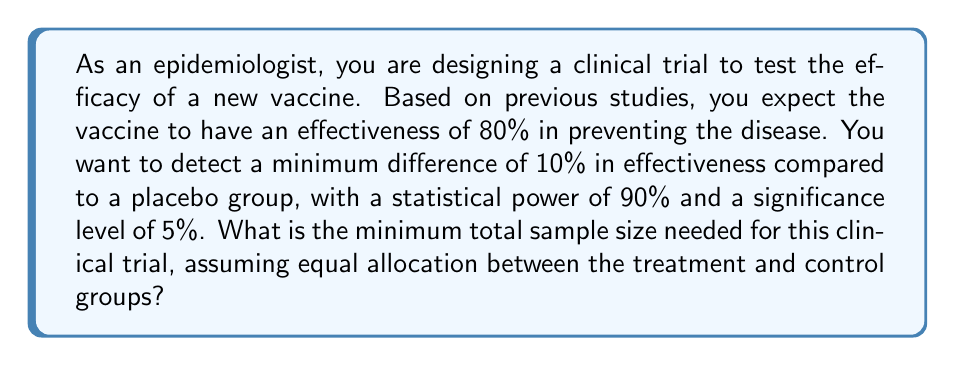What is the answer to this math problem? To calculate the sample size for this clinical trial, we'll use the formula for comparing two proportions:

$$ n = \frac{(z_{\alpha/2} + z_{\beta})^2 [p_1(1-p_1) + p_2(1-p_2)]}{(p_1 - p_2)^2} $$

Where:
- $n$ is the sample size per group
- $z_{\alpha/2}$ is the critical value of the normal distribution at $\alpha/2$
- $z_{\beta}$ is the critical value of the normal distribution at $\beta$
- $p_1$ is the expected proportion in the treatment group
- $p_2$ is the expected proportion in the control group

Given:
- $\alpha = 0.05$ (significance level)
- $1 - \beta = 0.90$ (power)
- $p_1 = 0.80$ (expected vaccine effectiveness)
- $p_2 = 0.70$ (placebo group, 10% less than vaccine group)

Step 1: Determine $z_{\alpha/2}$ and $z_{\beta}$
$z_{\alpha/2} = z_{0.025} = 1.96$ (for two-tailed test)
$z_{\beta} = z_{0.10} = 1.28$ (as power = 1 - $\beta$ = 0.90)

Step 2: Plug values into the formula
$$ n = \frac{(1.96 + 1.28)^2 [0.80(1-0.80) + 0.70(1-0.70)]}{(0.80 - 0.70)^2} $$

Step 3: Calculate
$$ n = \frac{10.5156 [0.16 + 0.21]}{0.01} = \frac{10.5156 \times 0.37}{0.01} = 389.08 $$

Step 4: Round up to the nearest whole number
$n = 390$ per group

Step 5: Calculate total sample size
Total sample size = $2n = 2 \times 390 = 780$
Answer: The minimum total sample size needed for this clinical trial is 780 participants, with 390 in each group. 